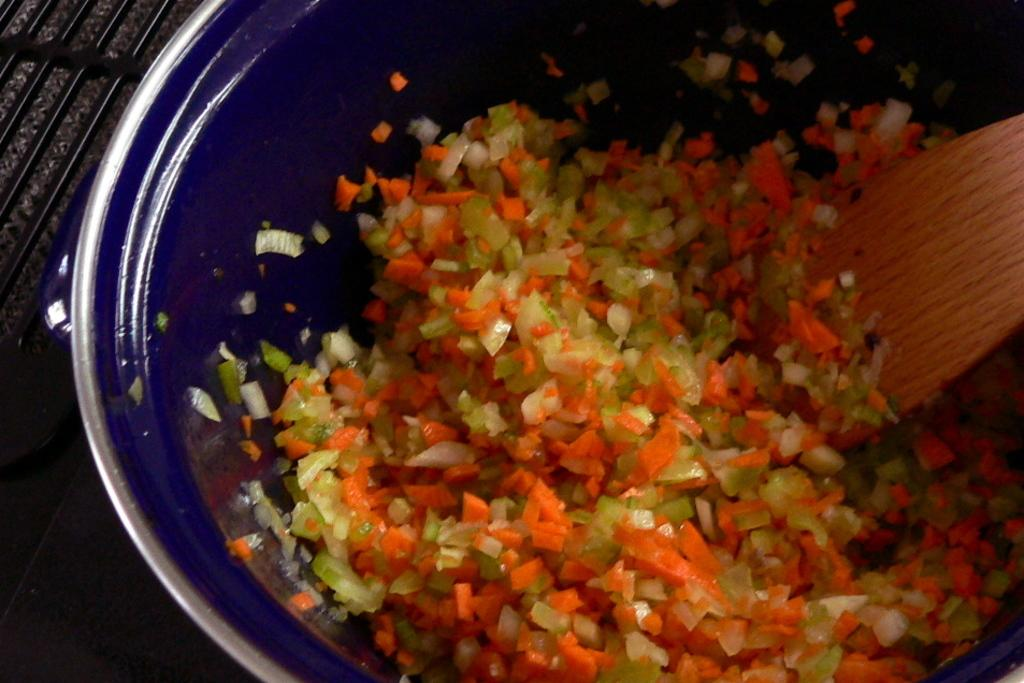What is on the plate that is visible in the image? There are chopped vegetables on a plate. What utensil can be seen in the image? There is a spoon present. Where is the plate with vegetables located? The plate with vegetables is kept on a table. What direction does the neck of the person in the image face? There is no person present in the image, so we cannot determine the direction their neck is facing. 